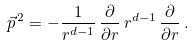Convert formula to latex. <formula><loc_0><loc_0><loc_500><loc_500>\vec { p } ^ { \, 2 } = - \frac { 1 } { r ^ { d - 1 } } \, \frac { \partial } { \partial r } \, r ^ { d - 1 } \, \frac { \partial } { \partial r } \, .</formula> 